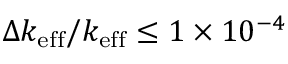<formula> <loc_0><loc_0><loc_500><loc_500>\Delta k _ { e f f } / k _ { e f f } \leq 1 \times 1 0 ^ { - 4 }</formula> 